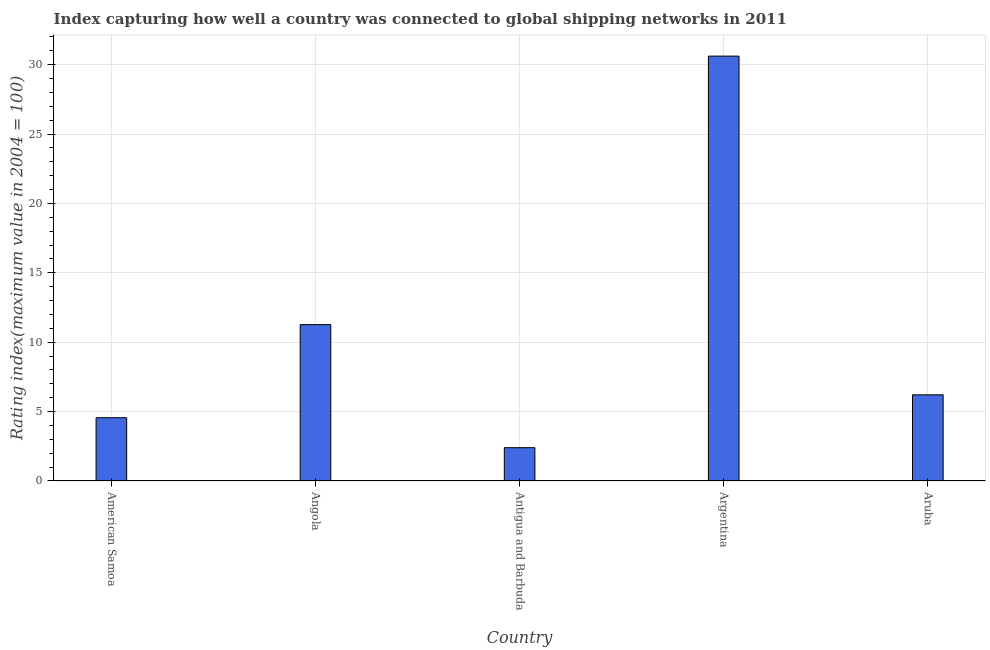Does the graph contain grids?
Offer a very short reply. Yes. What is the title of the graph?
Provide a short and direct response. Index capturing how well a country was connected to global shipping networks in 2011. What is the label or title of the X-axis?
Ensure brevity in your answer.  Country. What is the label or title of the Y-axis?
Make the answer very short. Rating index(maximum value in 2004 = 100). What is the liner shipping connectivity index in Angola?
Provide a succinct answer. 11.27. Across all countries, what is the maximum liner shipping connectivity index?
Provide a succinct answer. 30.62. Across all countries, what is the minimum liner shipping connectivity index?
Offer a very short reply. 2.4. In which country was the liner shipping connectivity index minimum?
Make the answer very short. Antigua and Barbuda. What is the sum of the liner shipping connectivity index?
Your response must be concise. 55.06. What is the difference between the liner shipping connectivity index in American Samoa and Argentina?
Make the answer very short. -26.06. What is the average liner shipping connectivity index per country?
Give a very brief answer. 11.01. What is the median liner shipping connectivity index?
Give a very brief answer. 6.21. In how many countries, is the liner shipping connectivity index greater than 3 ?
Make the answer very short. 4. What is the ratio of the liner shipping connectivity index in Angola to that in Argentina?
Your answer should be very brief. 0.37. What is the difference between the highest and the second highest liner shipping connectivity index?
Provide a short and direct response. 19.35. Is the sum of the liner shipping connectivity index in Antigua and Barbuda and Argentina greater than the maximum liner shipping connectivity index across all countries?
Your answer should be very brief. Yes. What is the difference between the highest and the lowest liner shipping connectivity index?
Keep it short and to the point. 28.22. How many countries are there in the graph?
Offer a terse response. 5. What is the difference between two consecutive major ticks on the Y-axis?
Your response must be concise. 5. What is the Rating index(maximum value in 2004 = 100) in American Samoa?
Give a very brief answer. 4.56. What is the Rating index(maximum value in 2004 = 100) of Angola?
Your response must be concise. 11.27. What is the Rating index(maximum value in 2004 = 100) of Argentina?
Provide a short and direct response. 30.62. What is the Rating index(maximum value in 2004 = 100) in Aruba?
Your response must be concise. 6.21. What is the difference between the Rating index(maximum value in 2004 = 100) in American Samoa and Angola?
Keep it short and to the point. -6.71. What is the difference between the Rating index(maximum value in 2004 = 100) in American Samoa and Antigua and Barbuda?
Provide a short and direct response. 2.16. What is the difference between the Rating index(maximum value in 2004 = 100) in American Samoa and Argentina?
Your answer should be compact. -26.06. What is the difference between the Rating index(maximum value in 2004 = 100) in American Samoa and Aruba?
Provide a succinct answer. -1.65. What is the difference between the Rating index(maximum value in 2004 = 100) in Angola and Antigua and Barbuda?
Your answer should be compact. 8.87. What is the difference between the Rating index(maximum value in 2004 = 100) in Angola and Argentina?
Keep it short and to the point. -19.35. What is the difference between the Rating index(maximum value in 2004 = 100) in Angola and Aruba?
Offer a very short reply. 5.06. What is the difference between the Rating index(maximum value in 2004 = 100) in Antigua and Barbuda and Argentina?
Your answer should be compact. -28.22. What is the difference between the Rating index(maximum value in 2004 = 100) in Antigua and Barbuda and Aruba?
Make the answer very short. -3.81. What is the difference between the Rating index(maximum value in 2004 = 100) in Argentina and Aruba?
Your answer should be very brief. 24.41. What is the ratio of the Rating index(maximum value in 2004 = 100) in American Samoa to that in Angola?
Your answer should be very brief. 0.41. What is the ratio of the Rating index(maximum value in 2004 = 100) in American Samoa to that in Antigua and Barbuda?
Keep it short and to the point. 1.9. What is the ratio of the Rating index(maximum value in 2004 = 100) in American Samoa to that in Argentina?
Provide a short and direct response. 0.15. What is the ratio of the Rating index(maximum value in 2004 = 100) in American Samoa to that in Aruba?
Keep it short and to the point. 0.73. What is the ratio of the Rating index(maximum value in 2004 = 100) in Angola to that in Antigua and Barbuda?
Provide a succinct answer. 4.7. What is the ratio of the Rating index(maximum value in 2004 = 100) in Angola to that in Argentina?
Provide a succinct answer. 0.37. What is the ratio of the Rating index(maximum value in 2004 = 100) in Angola to that in Aruba?
Ensure brevity in your answer.  1.81. What is the ratio of the Rating index(maximum value in 2004 = 100) in Antigua and Barbuda to that in Argentina?
Give a very brief answer. 0.08. What is the ratio of the Rating index(maximum value in 2004 = 100) in Antigua and Barbuda to that in Aruba?
Keep it short and to the point. 0.39. What is the ratio of the Rating index(maximum value in 2004 = 100) in Argentina to that in Aruba?
Offer a very short reply. 4.93. 